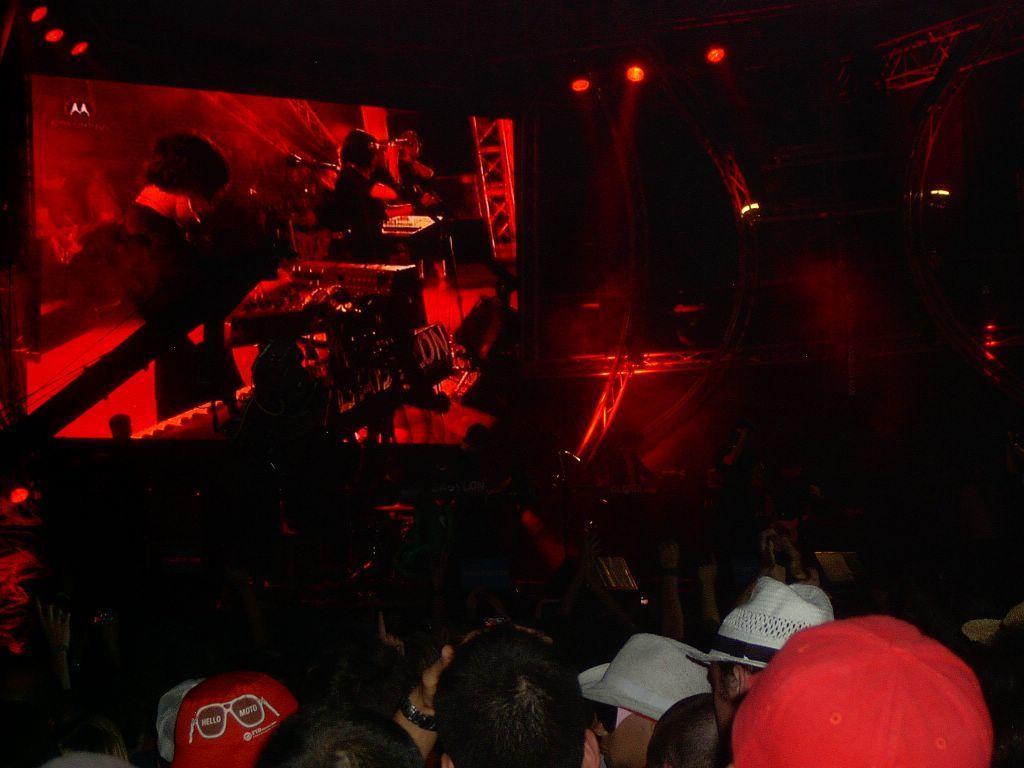Could you give a brief overview of what you see in this image? In the image there are few people sitting on chairs and in the back it seems to be a screen and there are red lights on the ceiling. 